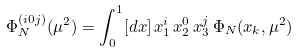<formula> <loc_0><loc_0><loc_500><loc_500>\Phi _ { N } ^ { ( i 0 j ) } ( \mu ^ { 2 } ) = \int _ { 0 } ^ { 1 } [ d x ] \, x _ { 1 } ^ { i } \, x _ { 2 } ^ { 0 } \, x _ { 3 } ^ { j } \, \Phi _ { N } ( x _ { k } , \mu ^ { 2 } )</formula> 